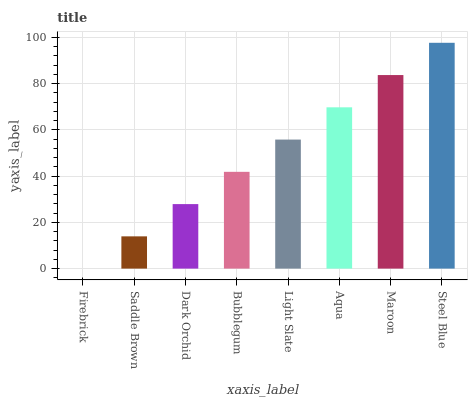Is Firebrick the minimum?
Answer yes or no. Yes. Is Steel Blue the maximum?
Answer yes or no. Yes. Is Saddle Brown the minimum?
Answer yes or no. No. Is Saddle Brown the maximum?
Answer yes or no. No. Is Saddle Brown greater than Firebrick?
Answer yes or no. Yes. Is Firebrick less than Saddle Brown?
Answer yes or no. Yes. Is Firebrick greater than Saddle Brown?
Answer yes or no. No. Is Saddle Brown less than Firebrick?
Answer yes or no. No. Is Light Slate the high median?
Answer yes or no. Yes. Is Bubblegum the low median?
Answer yes or no. Yes. Is Maroon the high median?
Answer yes or no. No. Is Firebrick the low median?
Answer yes or no. No. 